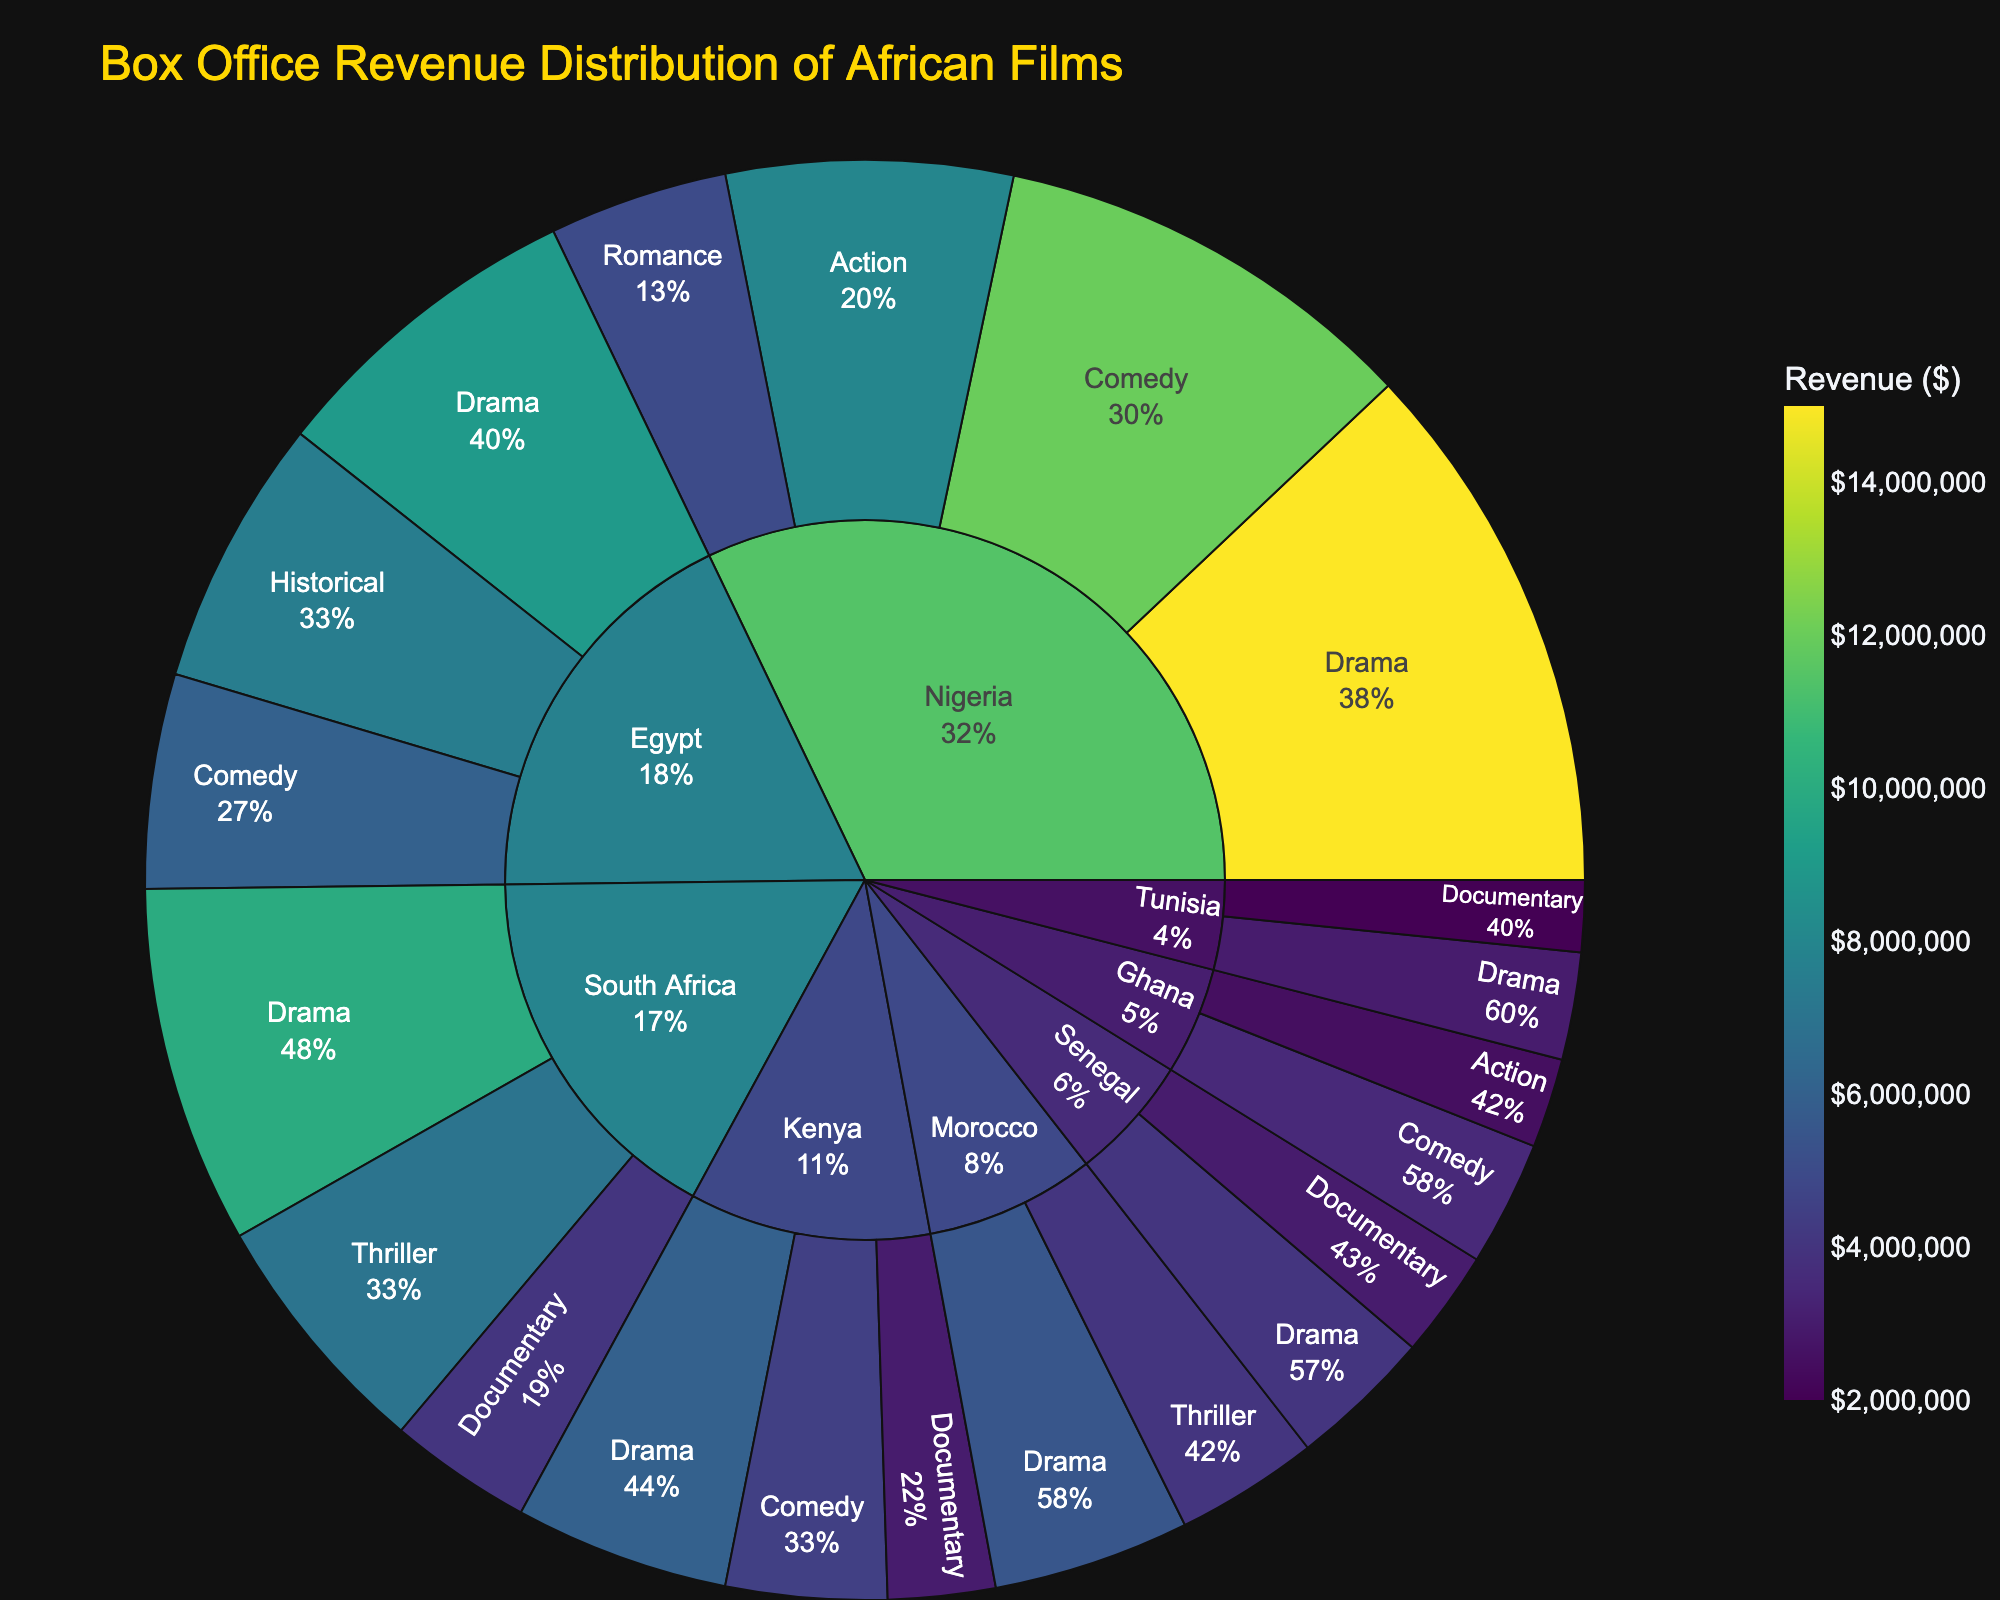Which country generates the highest total box office revenue? To determine this, sum the revenues for each genre within each country. Nigeria has the highest revenue with a sum of 15,000,000 (Drama) + 12,000,000 (Comedy) + 8,000,000 (Action) + 5,000,000 (Romance) = 40,000,000.
Answer: Nigeria What's the total box office revenue for drama films in all countries combined? Sum the revenues of the drama genre across all countries: 15,000,000 (Nigeria) + 10,000,000 (South Africa) + 6,000,000 (Kenya) + 9,000,000 (Egypt) + 4,000,000 (Senegal) + 5,500,000 (Morocco) + 3,000,000 (Tunisia) = 52,500,000.
Answer: $52,500,000 Which genre generates the highest revenue in South Africa? By observing the sunburst plot for South Africa, the drama genre generates 10,000,000, thriller generates 7,000,000, and documentary generates 4,000,000. Thus, drama has the highest revenue.
Answer: Drama Compare the revenue of comedy films between Nigeria and Kenya. Which one is greater and by how much? Nigeria's comedy genre has a revenue of 12,000,000, while Kenya's comedy genre has 4,500,000. The difference is 12,000,000 - 4,500,000 = 7,500,000.
Answer: Nigeria by $7,500,000 What is the percentage of Nigeria's box office revenue coming from action films relative to its total revenue? Nigeria's total revenue is 40,000,000. The action film revenue is 8,000,000. The percentage is (8,000,000 / 40,000,000) * 100% = 20%.
Answer: 20% How does the revenue from Senegal's drama films compare to Tunisia's drama films? Senegal's drama revenue is 4,000,000, while Tunisia's drama revenue is 3,000,000. So, Senegal's drama films generate 4,000,000 - 3,000,000 = 1,000,000 more than Tunisia's drama films.
Answer: $1,000,000 more Which country has the lowest revenue from the documentary genre and what is the amount? By examining the documentary revenues, Tunisia has the lowest with 2,000,000.
Answer: Tunisia What proportion of Kenya's total box office revenue comes from documentary films? Kenya's total revenue is 6,000,000 (Drama) + 4,500,000 (Comedy) + 3,000,000 (Documentary) = 13,500,000. The documentary revenue proportion is (3,000,000 / 13,500,000) * 100% ≈ 22.22%.
Answer: 22.22% Between Morocco and Egypt, which country generates more total revenue and by how much? Morocco: 5,500,000 (Drama) + 4,000,000 (Thriller) = 9,500,000. Egypt: 9,000,000 (Drama) + 7,500,000 (Historical) + 6,000,000 (Comedy) = 22,500,000. Difference is 22,500,000 - 9,500,000 = 13,000,000 more for Egypt.
Answer: Egypt by $13,000,000 